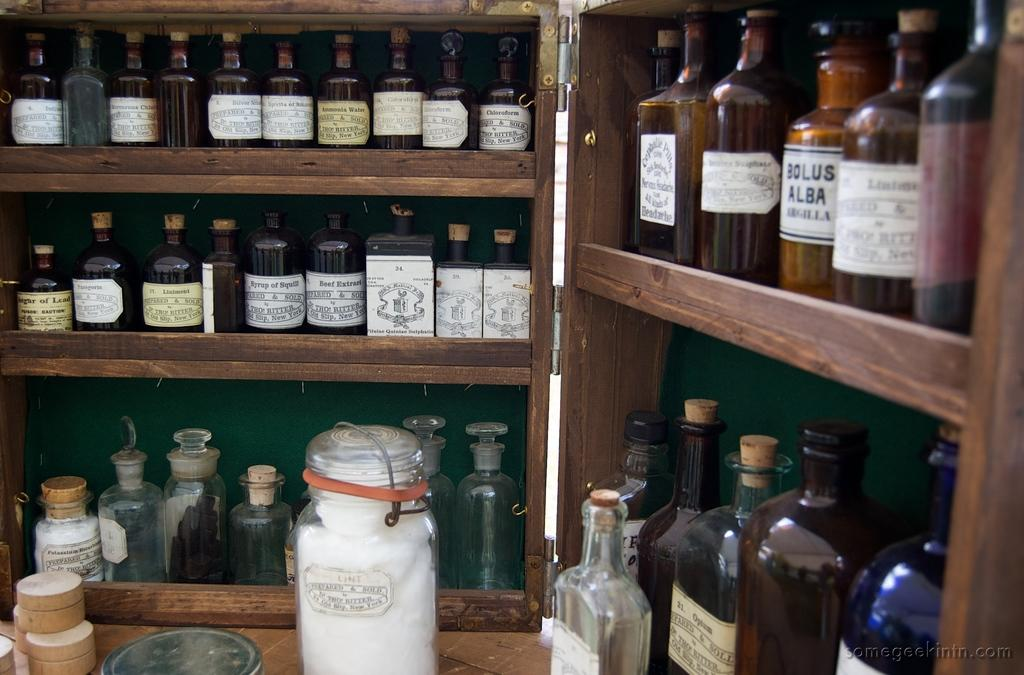What objects are present in the image? There is a group of glass bottles in the image. How are the glass bottles arranged or positioned? The glass bottles are placed on a wooden stand. Can you hear the glass bottles laughing in the image? There is no sound or indication of laughter in the image, as it is a still photograph. 